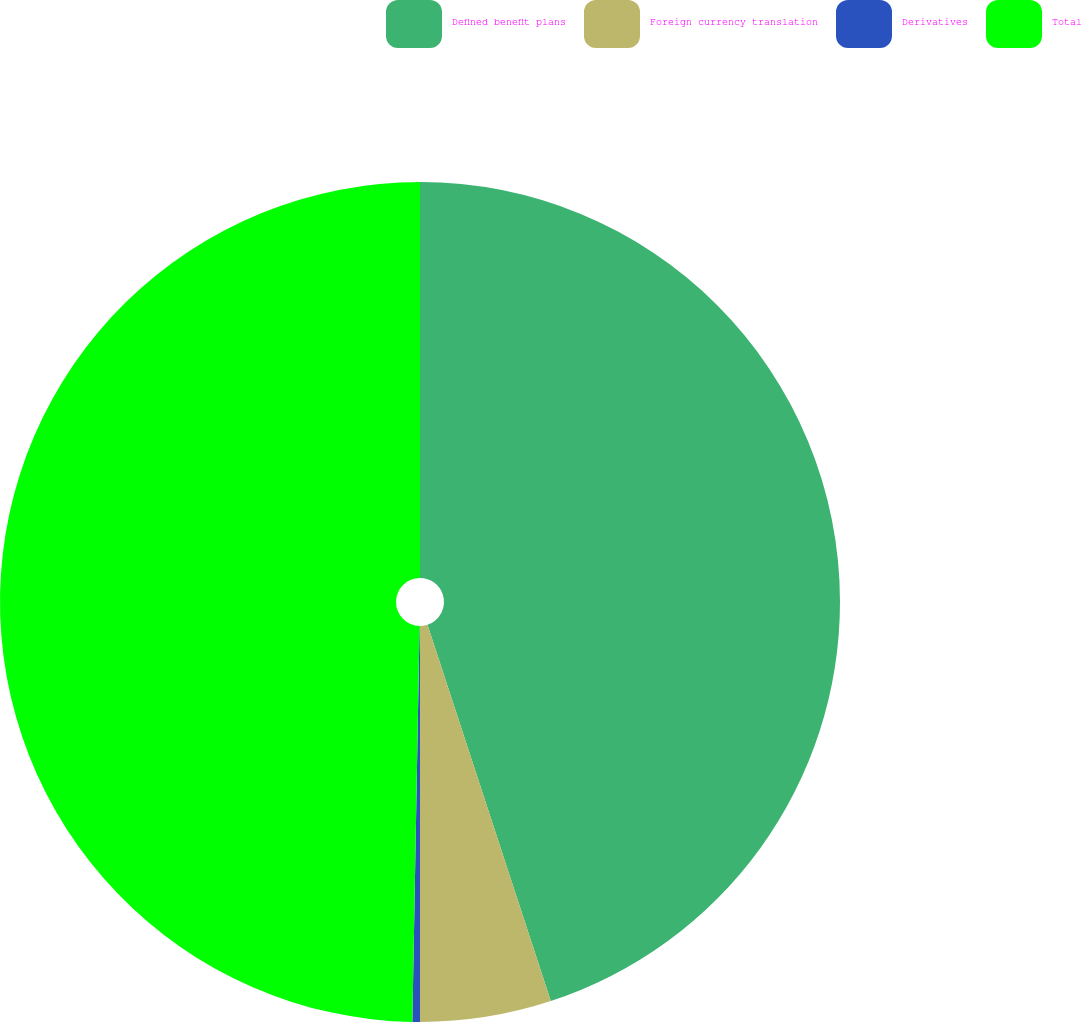Convert chart. <chart><loc_0><loc_0><loc_500><loc_500><pie_chart><fcel>Defined benefit plans<fcel>Foreign currency translation<fcel>Derivatives<fcel>Total<nl><fcel>44.96%<fcel>5.04%<fcel>0.29%<fcel>49.71%<nl></chart> 